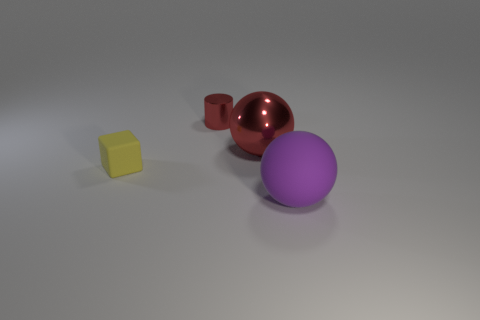Add 4 big rubber objects. How many objects exist? 8 Subtract all cubes. How many objects are left? 3 Subtract all big gray rubber cylinders. Subtract all small blocks. How many objects are left? 3 Add 3 spheres. How many spheres are left? 5 Add 3 tiny gray matte blocks. How many tiny gray matte blocks exist? 3 Subtract 0 green balls. How many objects are left? 4 